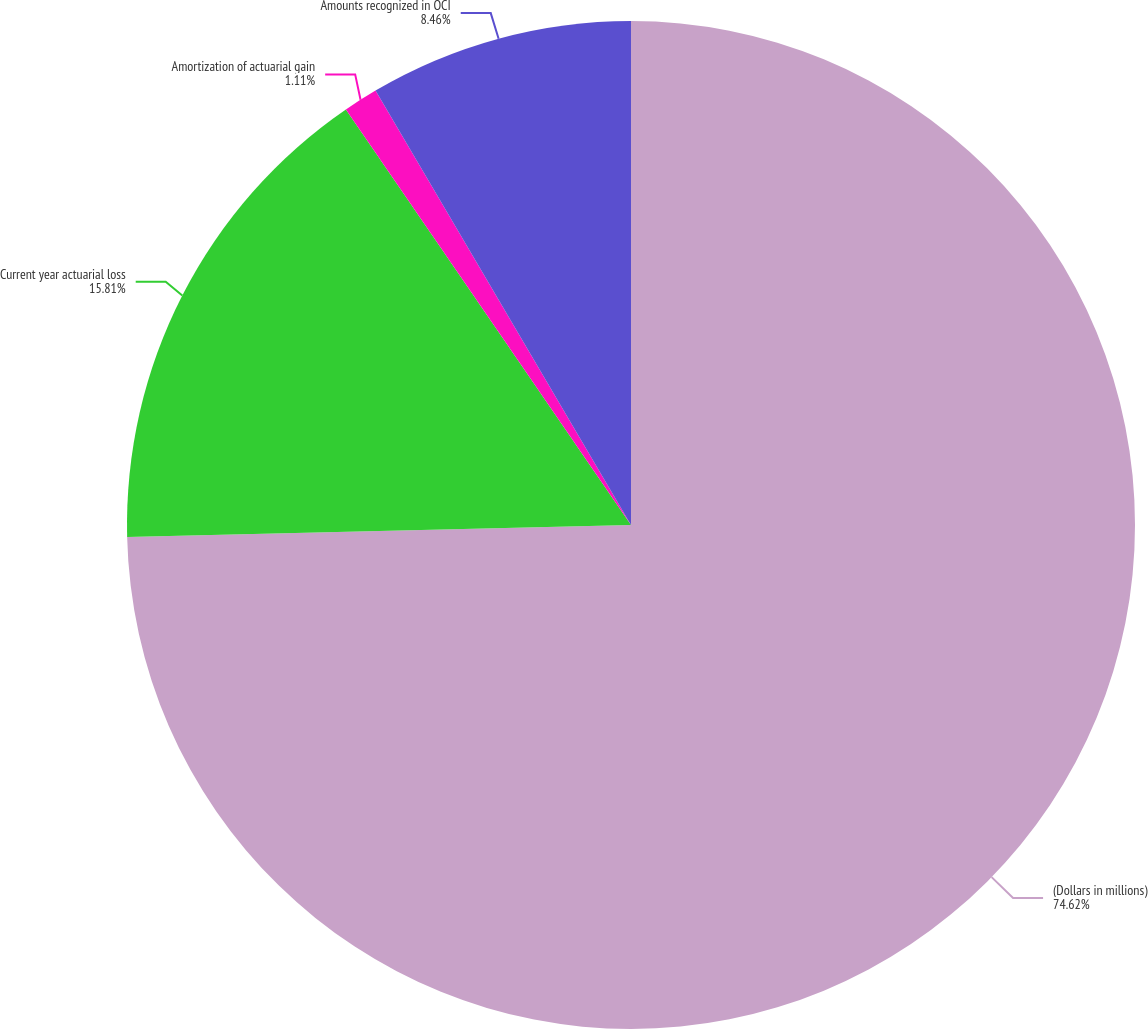Convert chart to OTSL. <chart><loc_0><loc_0><loc_500><loc_500><pie_chart><fcel>(Dollars in millions)<fcel>Current year actuarial loss<fcel>Amortization of actuarial gain<fcel>Amounts recognized in OCI<nl><fcel>74.62%<fcel>15.81%<fcel>1.11%<fcel>8.46%<nl></chart> 